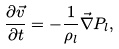Convert formula to latex. <formula><loc_0><loc_0><loc_500><loc_500>\frac { \partial { \vec { v } } } { \partial t } = - \frac { 1 } { \rho _ { l } } \vec { \nabla } P _ { l } ,</formula> 